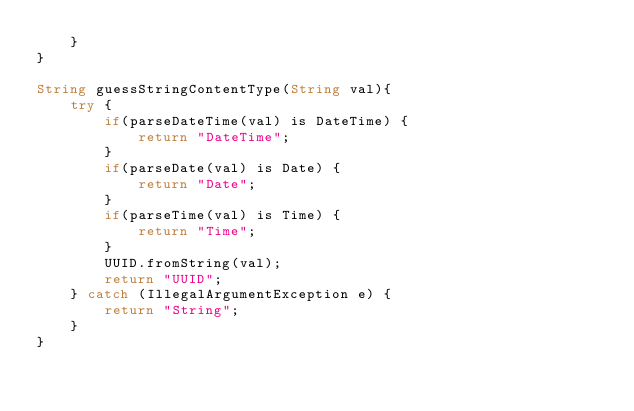<code> <loc_0><loc_0><loc_500><loc_500><_Ceylon_>    }
}

String guessStringContentType(String val){
    try {
        if(parseDateTime(val) is DateTime) {
            return "DateTime";
        }
        if(parseDate(val) is Date) {
            return "Date";
        }
        if(parseTime(val) is Time) {
            return "Time";
        }
        UUID.fromString(val);
        return "UUID";
    } catch (IllegalArgumentException e) {
        return "String";
    }
}
</code> 